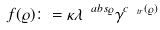<formula> <loc_0><loc_0><loc_500><loc_500>f ( \varrho ) \colon = \kappa \lambda ^ { \ a b s { \varrho } } \gamma ^ { c _ { \ t r } ( \varrho ) }</formula> 